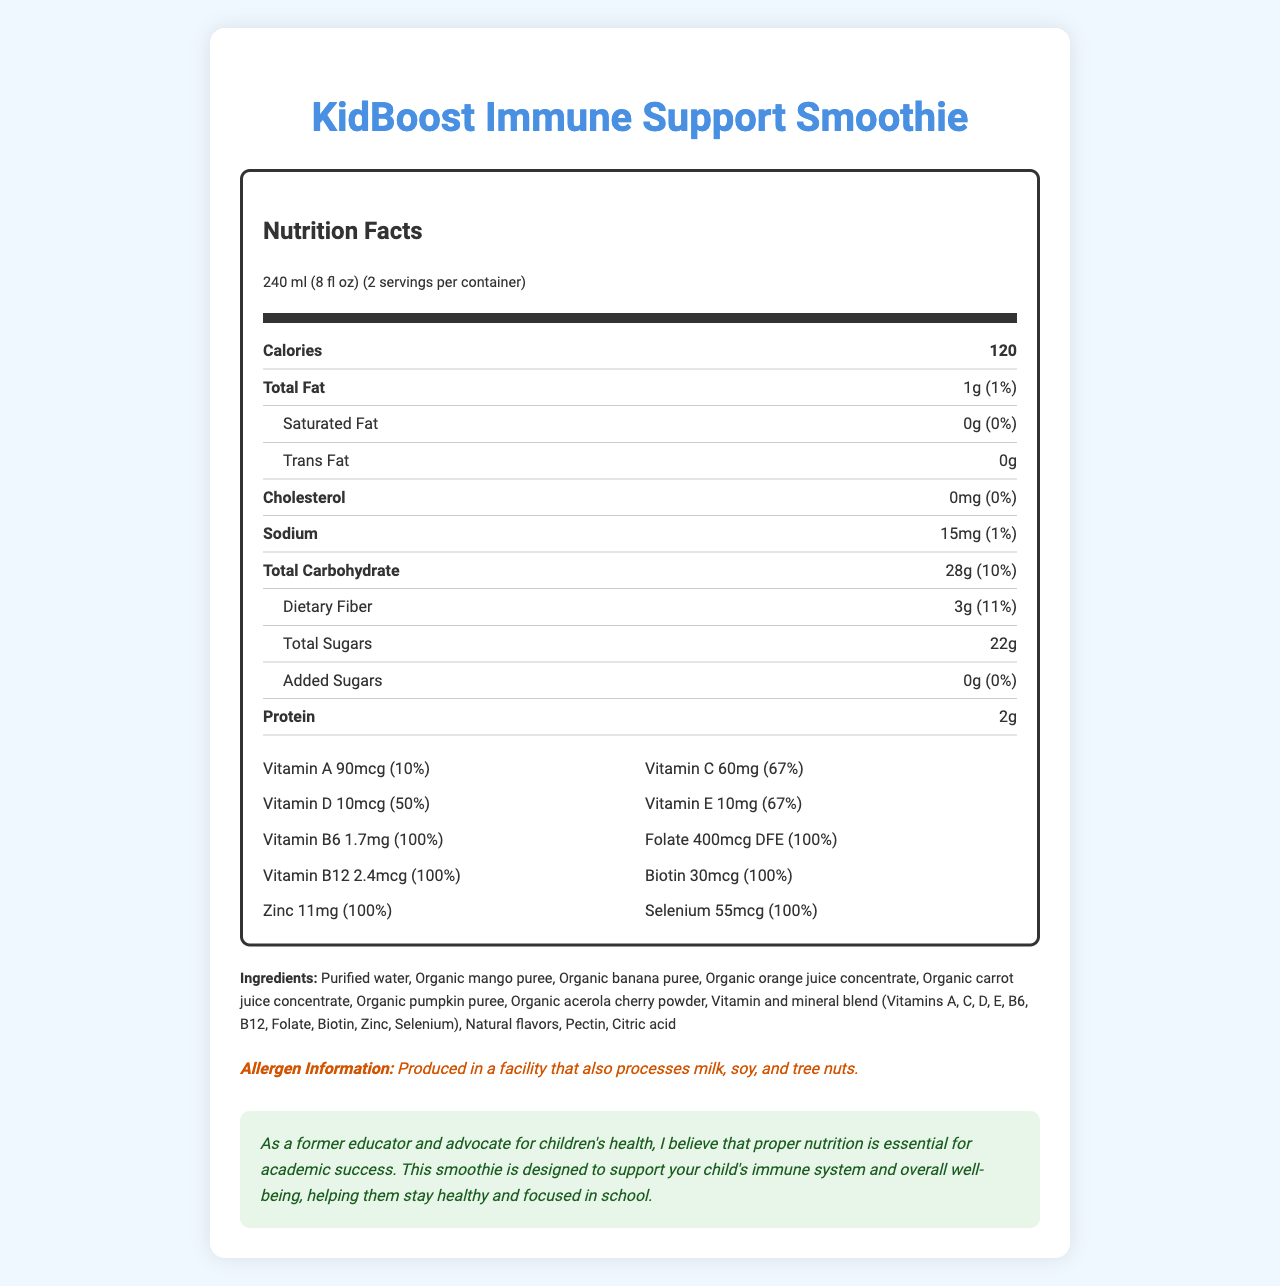what is the serving size of the KidBoost Immune Support Smoothie? The serving size is explicitly listed at the top of the Nutrition Facts label under "serving size."
Answer: 240 ml (8 fl oz) how many servings per container are there? The document states "2 servings per container" at the top of the Nutrition Facts label.
Answer: 2 what is the amount of carbohydrates in one serving? The "Total Carbohydrate" section indicates "28g."
Answer: 28g how much Vitamin C does one serving provide? The Vitamin C content is listed in the vitamin section with its amount: "60mg."
Answer: 60mg how many calories are in one serving of this smoothie? The document lists "Calories" as 120 at the top of the Nutrition Facts label.
Answer: 120 which of the following vitamins is present at 50% of the daily value in this smoothie?
A. Vitamin A
B. Vitamin C
C. Vitamin D
D. Vitamin E The document states that Vitamin D has an amount of "10mcg (50%)" which is 50% of the daily value.
Answer: C. Vitamin D how much protein does each serving contain?
A. 1g
B. 2g
C. 3g
D. 4g The protein content per serving is listed as "2g" under the "Protein" section.
Answer: B. 2g does this smoothie contain any trans fat? The document lists "Trans Fat" as "0g," indicating there is no trans fat in this smoothie.
Answer: No summarize the main idea of the document. The document combines nutritional data, ingredient list, and an educational message to present a comprehensive overview of the health benefits provided by the KidBoost Immune Support Smoothie.
Answer: The KidBoost Immune Support Smoothie is a vitamin-enriched beverage designed for children's immune support. Each 240ml serving contains 120 calories, various essential vitamins like Vitamin C, D, B6, and B12, and nutrients aimed to enhance children's health. The document highlights serving size, nutrient amounts, ingredients, and an educational message emphasizing the importance of nutrition for academic success. what is the allergen information for this smoothie? The allergen information is clearly stated near the bottom of the document.
Answer: Produced in a facility that also processes milk, soy, and tree nuts. how many grams of dietary fiber does one serving contain? The "Dietary Fiber" section indicates "3g."
Answer: 3g is there any added sugar in each serving of this smoothie? The document lists "Added Sugars" as "0g," indicating no added sugars.
Answer: No what is the daily value percentage of Vitamin E in each serving? The document lists Vitamin E with an amount of "10mg" and a daily value of 67%.
Answer: 67% what is the primary purpose of this smoothie as stated in the educational message? The educational message explains the smoothie is designed to support a child's immune system and well-being to help them stay focused and healthy in school.
Answer: To support children's immune system and overall well-being, helping them stay healthy and focused in school. is this smoothie organic? The document lists organic ingredients, but it does not verify whether the entire smoothie itself is certified organic. The label mentions "organic" for some individual components but does not confirm for the overall product.
Answer: Cannot be determined 